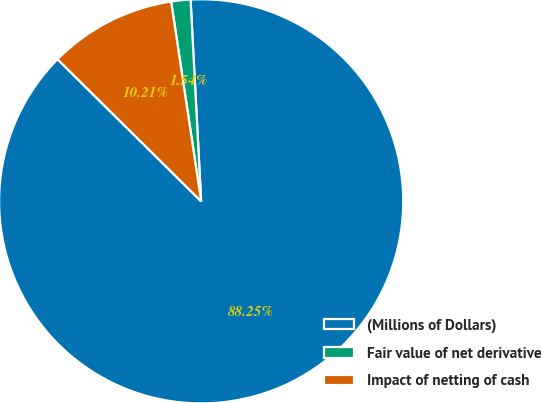Convert chart. <chart><loc_0><loc_0><loc_500><loc_500><pie_chart><fcel>(Millions of Dollars)<fcel>Fair value of net derivative<fcel>Impact of netting of cash<nl><fcel>88.25%<fcel>1.54%<fcel>10.21%<nl></chart> 